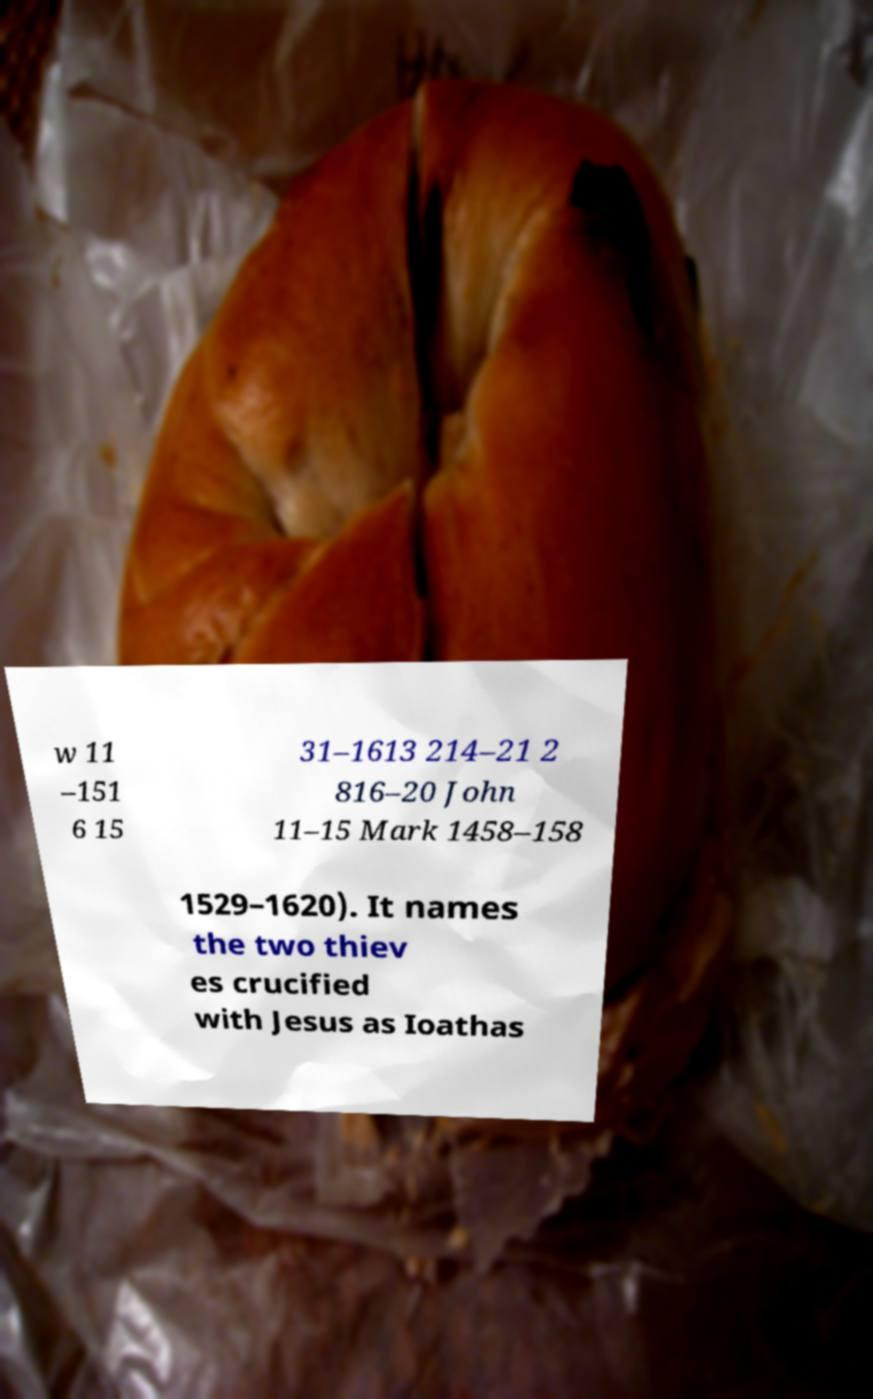Can you read and provide the text displayed in the image?This photo seems to have some interesting text. Can you extract and type it out for me? w 11 –151 6 15 31–1613 214–21 2 816–20 John 11–15 Mark 1458–158 1529–1620). It names the two thiev es crucified with Jesus as Ioathas 